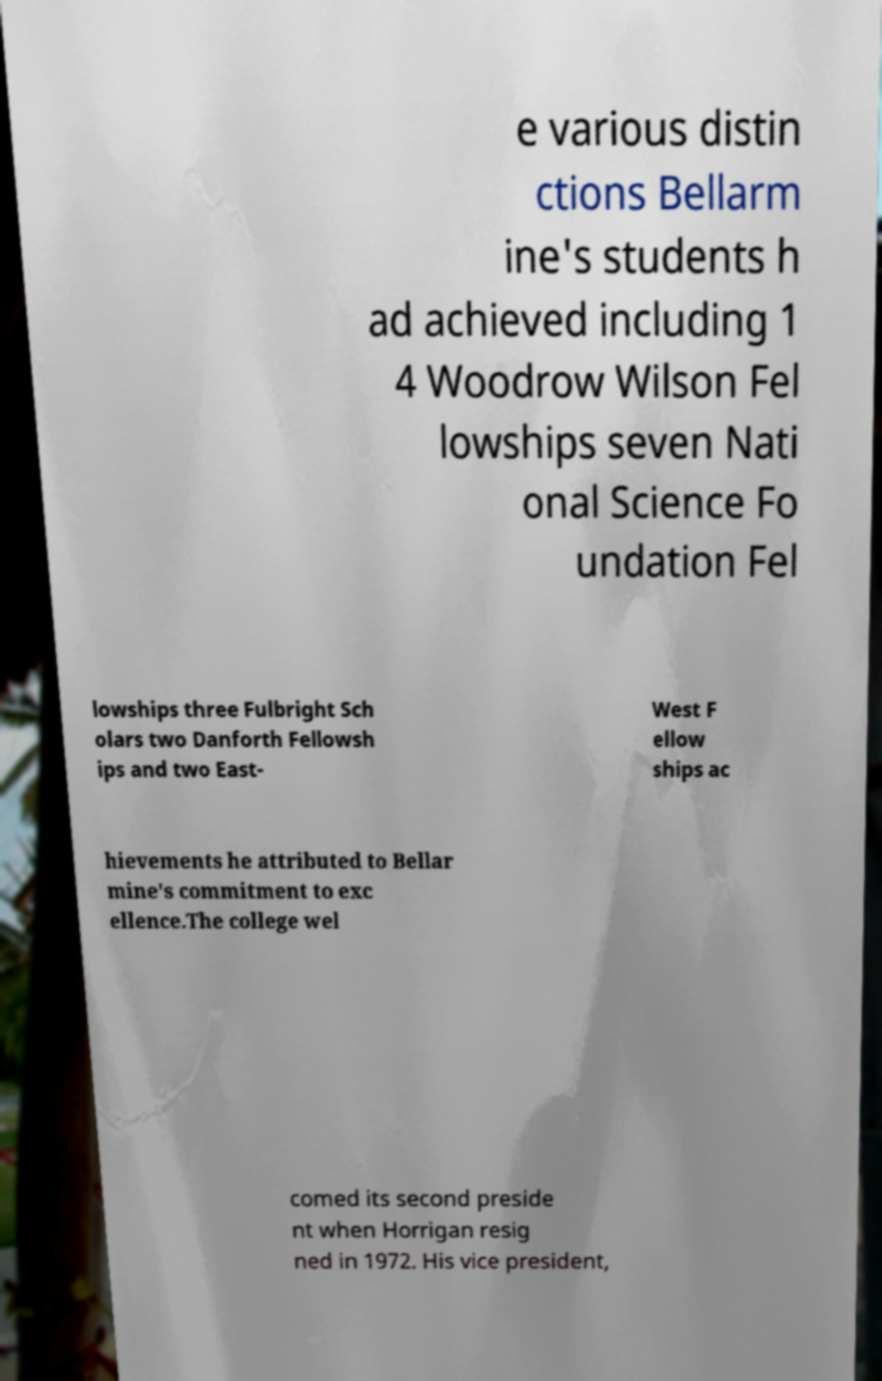Please identify and transcribe the text found in this image. e various distin ctions Bellarm ine's students h ad achieved including 1 4 Woodrow Wilson Fel lowships seven Nati onal Science Fo undation Fel lowships three Fulbright Sch olars two Danforth Fellowsh ips and two East- West F ellow ships ac hievements he attributed to Bellar mine's commitment to exc ellence.The college wel comed its second preside nt when Horrigan resig ned in 1972. His vice president, 